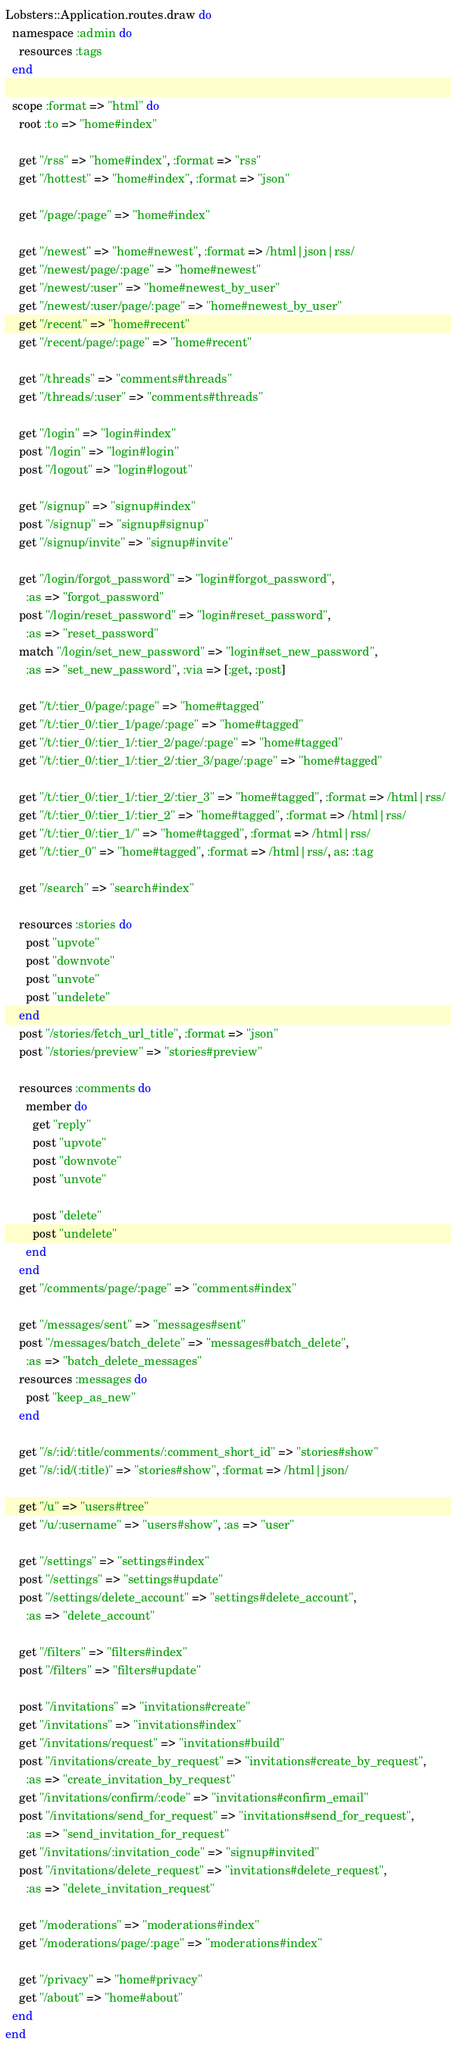Convert code to text. <code><loc_0><loc_0><loc_500><loc_500><_Ruby_>Lobsters::Application.routes.draw do
  namespace :admin do
    resources :tags
  end

  scope :format => "html" do
    root :to => "home#index"

    get "/rss" => "home#index", :format => "rss"
    get "/hottest" => "home#index", :format => "json"

    get "/page/:page" => "home#index"

    get "/newest" => "home#newest", :format => /html|json|rss/
    get "/newest/page/:page" => "home#newest"
    get "/newest/:user" => "home#newest_by_user"
    get "/newest/:user/page/:page" => "home#newest_by_user"
    get "/recent" => "home#recent"
    get "/recent/page/:page" => "home#recent"

    get "/threads" => "comments#threads"
    get "/threads/:user" => "comments#threads"

    get "/login" => "login#index"
    post "/login" => "login#login"
    post "/logout" => "login#logout"

    get "/signup" => "signup#index"
    post "/signup" => "signup#signup"
    get "/signup/invite" => "signup#invite"

    get "/login/forgot_password" => "login#forgot_password",
      :as => "forgot_password"
    post "/login/reset_password" => "login#reset_password",
      :as => "reset_password"
    match "/login/set_new_password" => "login#set_new_password",
      :as => "set_new_password", :via => [:get, :post]

    get "/t/:tier_0/page/:page" => "home#tagged"
    get "/t/:tier_0/:tier_1/page/:page" => "home#tagged"
    get "/t/:tier_0/:tier_1/:tier_2/page/:page" => "home#tagged"
    get "/t/:tier_0/:tier_1/:tier_2/:tier_3/page/:page" => "home#tagged"

    get "/t/:tier_0/:tier_1/:tier_2/:tier_3" => "home#tagged", :format => /html|rss/
    get "/t/:tier_0/:tier_1/:tier_2" => "home#tagged", :format => /html|rss/
    get "/t/:tier_0/:tier_1/" => "home#tagged", :format => /html|rss/
    get "/t/:tier_0" => "home#tagged", :format => /html|rss/, as: :tag

    get "/search" => "search#index"

    resources :stories do
      post "upvote"
      post "downvote"
      post "unvote"
      post "undelete"
    end
    post "/stories/fetch_url_title", :format => "json"
    post "/stories/preview" => "stories#preview"

    resources :comments do
      member do
        get "reply"
        post "upvote"
        post "downvote"
        post "unvote"

        post "delete"
        post "undelete"
      end
    end
    get "/comments/page/:page" => "comments#index"

    get "/messages/sent" => "messages#sent"
    post "/messages/batch_delete" => "messages#batch_delete",
      :as => "batch_delete_messages"
    resources :messages do
      post "keep_as_new"
    end

    get "/s/:id/:title/comments/:comment_short_id" => "stories#show"
    get "/s/:id/(:title)" => "stories#show", :format => /html|json/

    get "/u" => "users#tree"
    get "/u/:username" => "users#show", :as => "user"

    get "/settings" => "settings#index"
    post "/settings" => "settings#update"
    post "/settings/delete_account" => "settings#delete_account",
      :as => "delete_account"

    get "/filters" => "filters#index"
    post "/filters" => "filters#update"

    post "/invitations" => "invitations#create"
    get "/invitations" => "invitations#index"
    get "/invitations/request" => "invitations#build"
    post "/invitations/create_by_request" => "invitations#create_by_request",
      :as => "create_invitation_by_request"
    get "/invitations/confirm/:code" => "invitations#confirm_email"
    post "/invitations/send_for_request" => "invitations#send_for_request",
      :as => "send_invitation_for_request"
    get "/invitations/:invitation_code" => "signup#invited"
    post "/invitations/delete_request" => "invitations#delete_request",
      :as => "delete_invitation_request"

    get "/moderations" => "moderations#index"
    get "/moderations/page/:page" => "moderations#index"

    get "/privacy" => "home#privacy"
    get "/about" => "home#about"
  end
end
</code> 